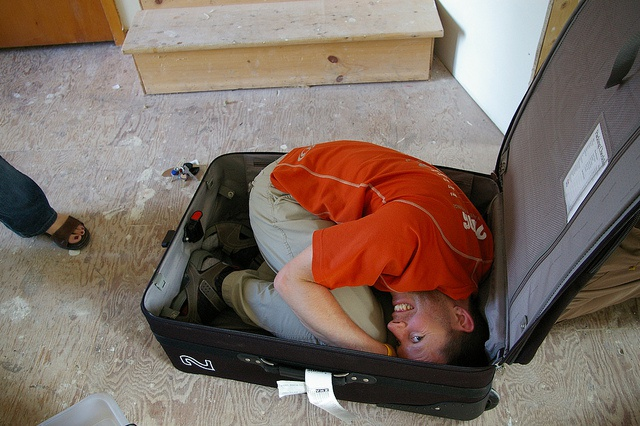Describe the objects in this image and their specific colors. I can see suitcase in maroon, black, gray, and darkgray tones, people in maroon, brown, black, and darkgray tones, and people in maroon, black, darkblue, brown, and gray tones in this image. 